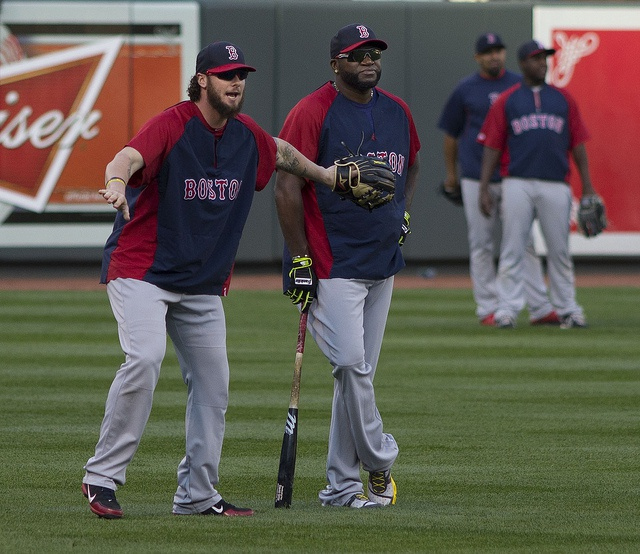Describe the objects in this image and their specific colors. I can see people in black, darkgray, gray, and maroon tones, people in black, gray, and darkgray tones, people in black, darkgray, gray, and maroon tones, people in black, navy, and gray tones, and baseball glove in black, gray, and darkgreen tones in this image. 